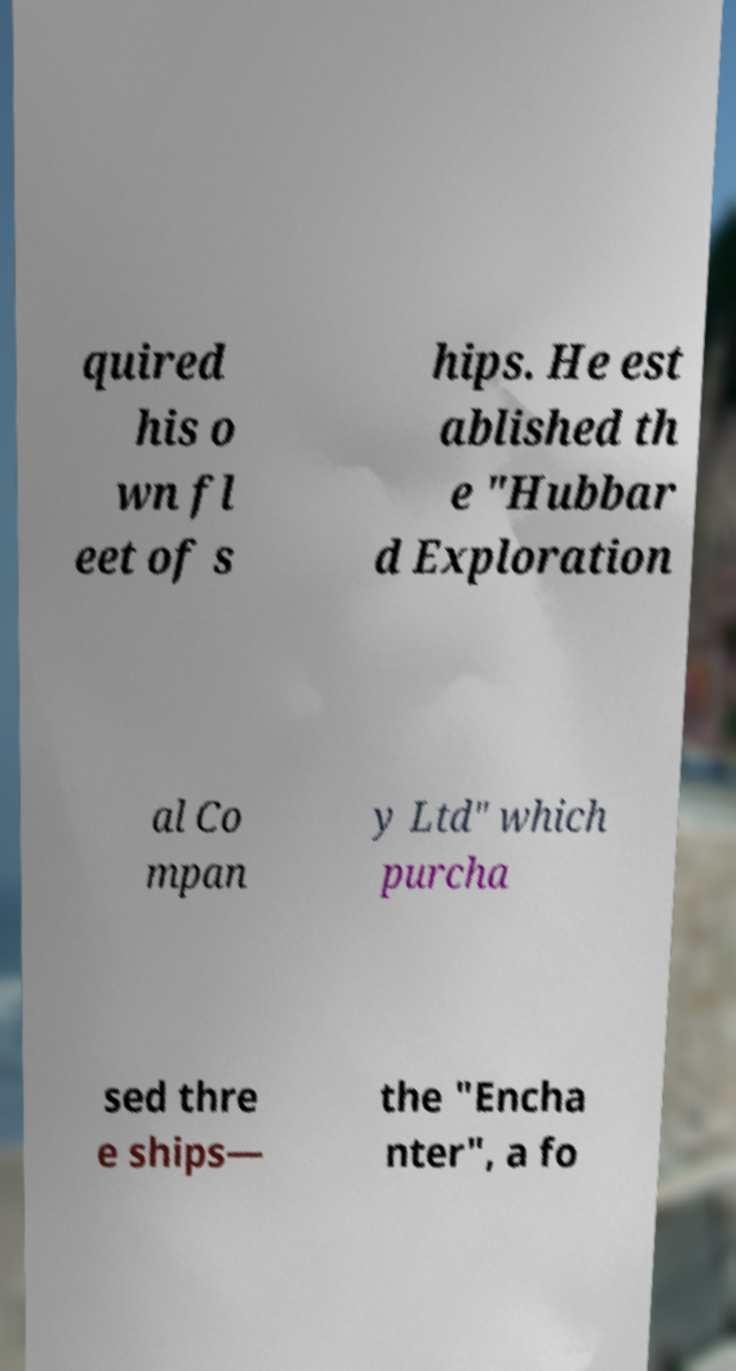Can you read and provide the text displayed in the image?This photo seems to have some interesting text. Can you extract and type it out for me? quired his o wn fl eet of s hips. He est ablished th e "Hubbar d Exploration al Co mpan y Ltd" which purcha sed thre e ships— the "Encha nter", a fo 